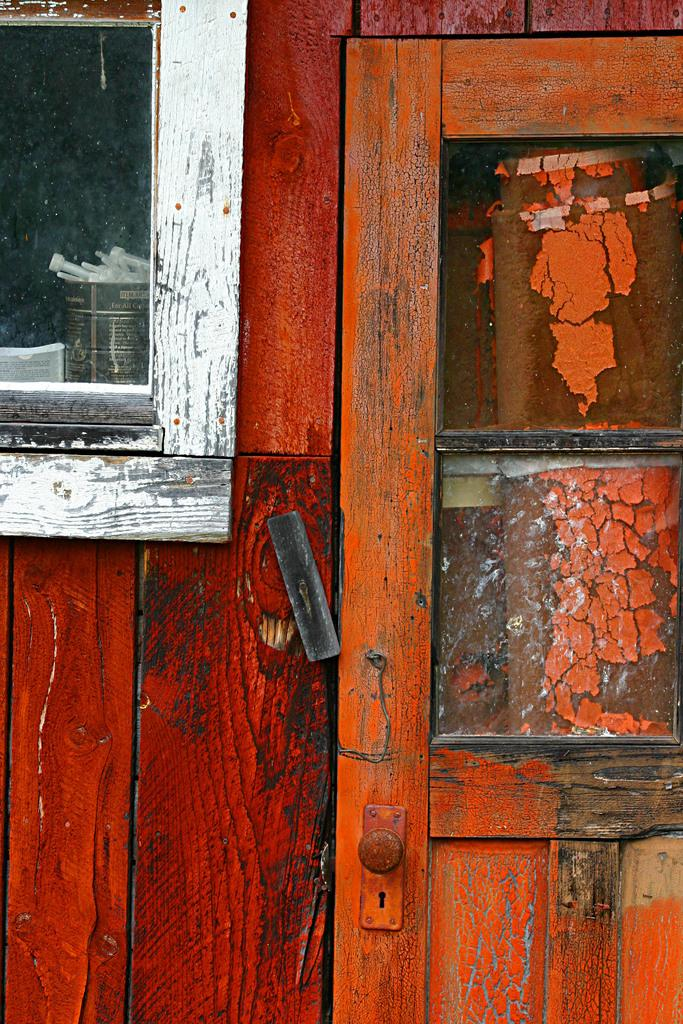What type of door is visible in the image? There is a wooden door in the image. Can you describe any other objects in the image besides the door? Unfortunately, the provided facts only mention the presence of a wooden door, so we cannot describe any other objects in the image. How many rabbits are sitting on the boat in the image? There is no boat or rabbits present in the image; it only features a wooden door. 